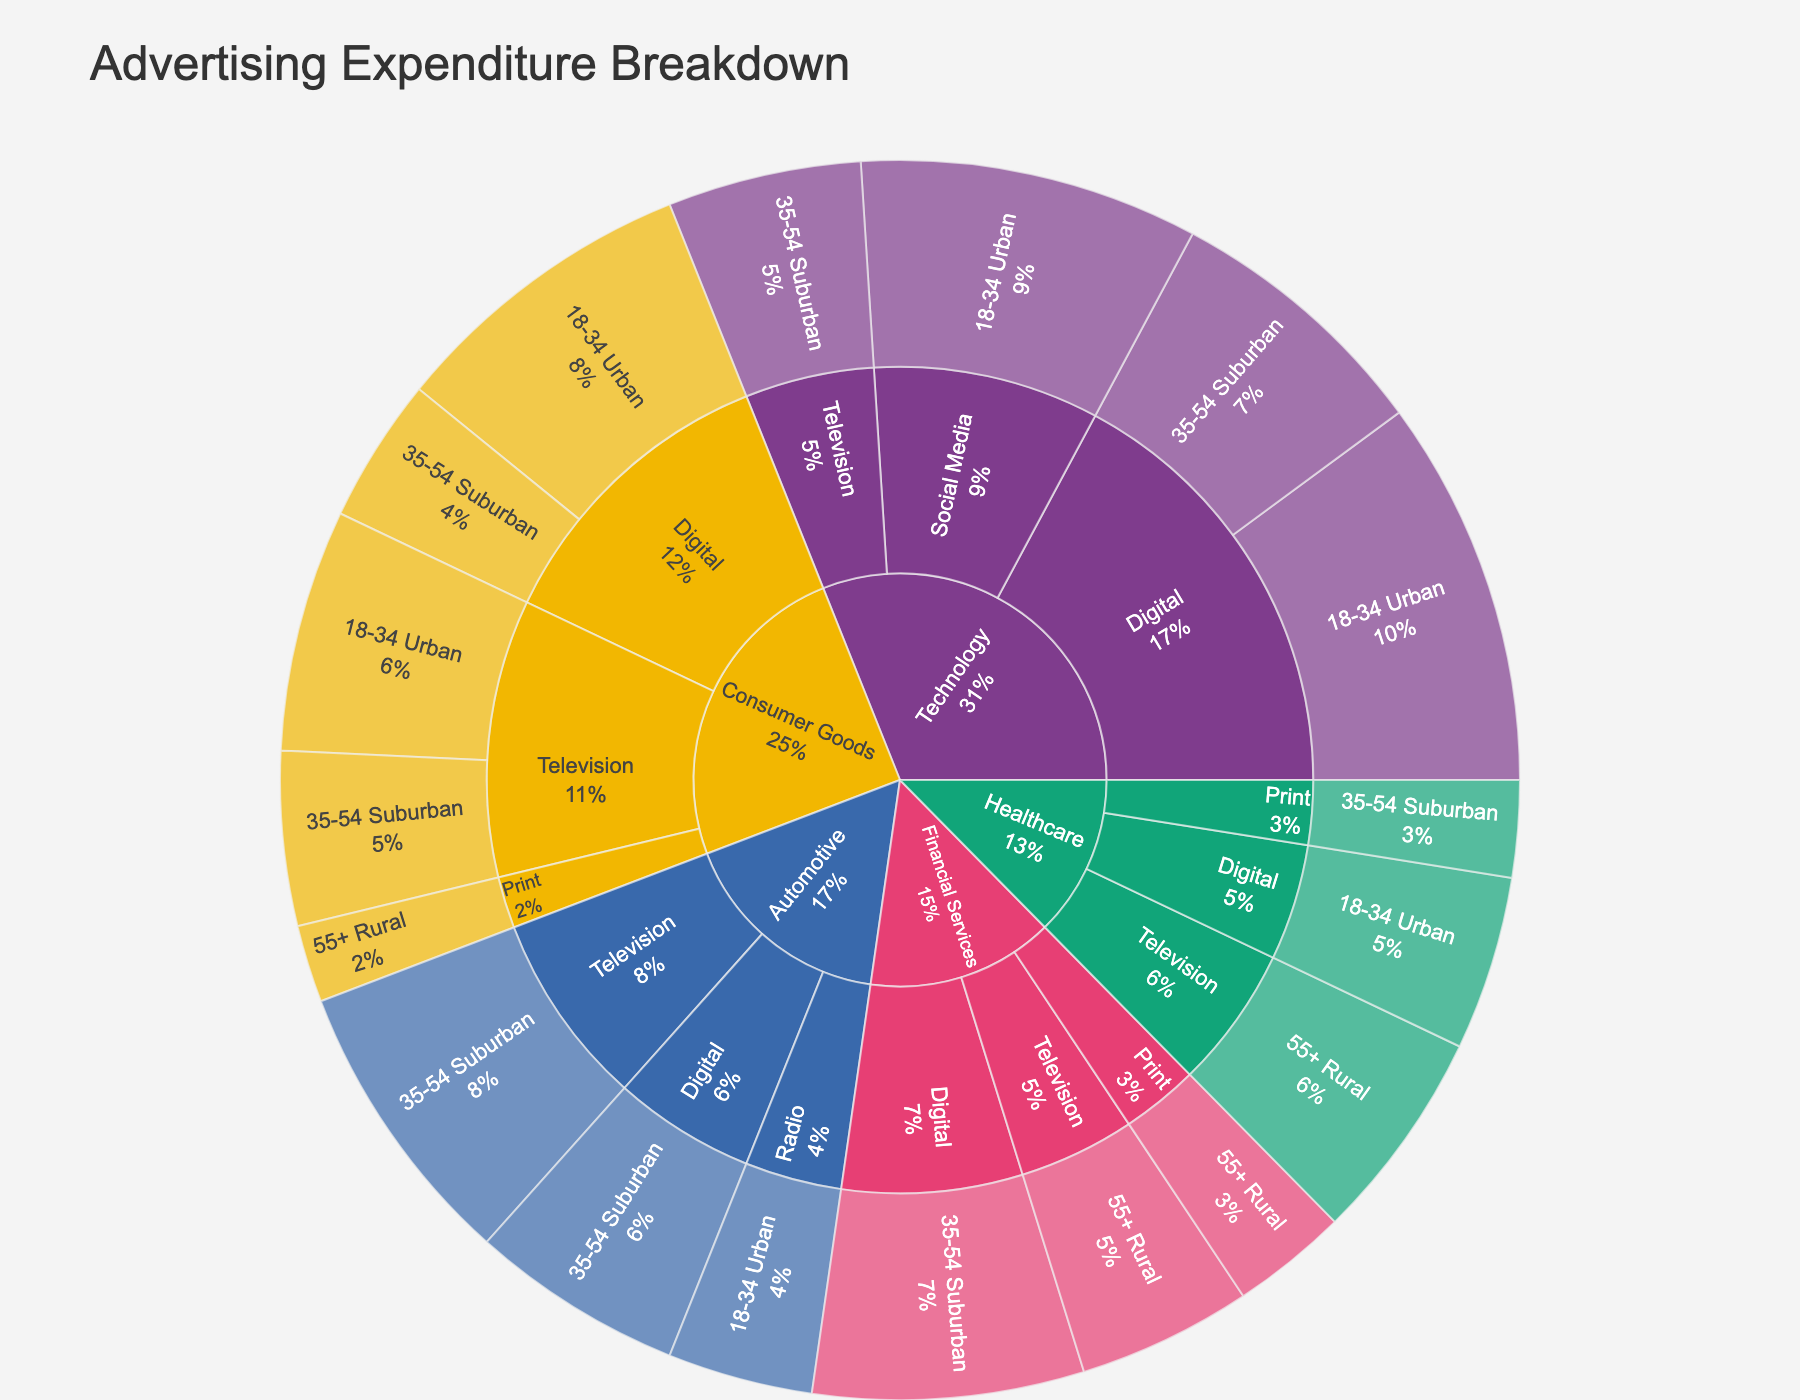what is the title of the plot? The title of the plot is displayed at the top of the figure. It provides context about what the data visualization represents. The title is "Advertising Expenditure Breakdown".
Answer: Advertising Expenditure Breakdown which industry has the highest total advertising expenditure? To find the industry with the highest expenditure, look at the sunburst plot, which visualizes hierarchical data. The outermost layer represents industries, and their expenditure is depicted by the size of their segment. The industry with the largest segment will have the highest expenditure. From the data, "Technology" has the highest total expenditure.
Answer: Technology how much did consumer goods invest in digital advertising? Find the "Consumer Goods" segment in the plot, drill down to "Digital" within it, and sum the expenditures for each demographic. From the data, "Consumer Goods" spends 320,000 on "18-34 Urban" + 150,000 on "35-54 Suburban" demographic for digital advertising.
Answer: 470,000 what is the total expenditure on print advertising for all industries? To find the total expenditure on print advertising, sum the expenditures for "Print" across all industries. The expenditures are 80,000 (Consumer Goods) + 120,000 (Financial Services) + 100,000 (Healthcare).
Answer: 300,000 which demographic has the least advertising expenditure? To determine the demographic with the least expenditure, compare the size of the segments representing demographics across all industries and mediums. The smallest segment corresponds to "55+ Rural" demographic under "Consumer Goods" with an expenditure of 80,000.
Answer: 55+ Rural which medium did the automotive industry spend the most on? Find the "Automotive" segment, then drill down to see the different mediums. Compare the segments representing different mediums to identify which one has the largest expenditure. Automotive spends the most on "Television" with an expenditure of 300,000.
Answer: Television compare the total digital advertising expenditure between technology and financial services industries. Sum the expenditures for "Digital" under both "Technology" and "Financial Services". Technology has 400,000 ("18-34 Urban") + 280,000 ("35-54 Suburban"), and Financial Services has 280,000 ("35-54 Suburban"). Summing these gives Technology 680,000 and Financial Services 280,000.
Answer: Technology: 680,000, Financial Services: 280,000 which industry has the smallest total advertising expenditure, and how much is it? Determine the industry with the smallest segment in the plot, representing the tiniest expenditure. The "Healthcare" industry has the smallest total expenditure visualized by the smallest segment. Summing up its expenditures gives us: 220,000 (Television, 55+ Rural) + 100,000 (Print, 35-54 Suburban) + 180,000 (Digital, 18-34 Urban) = 500,000.
Answer: Healthcare, 500,000 